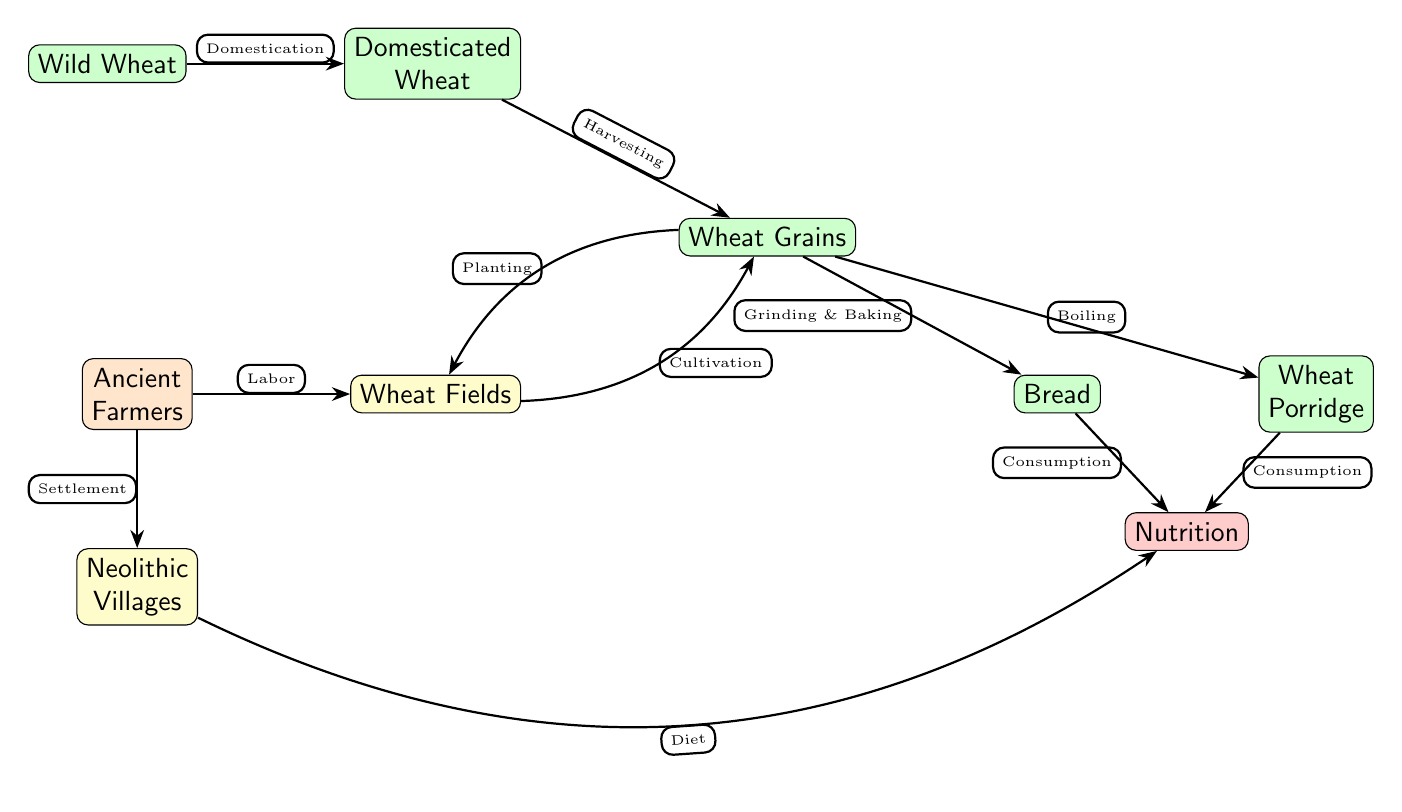What is the first node in the diagram? The first node in the diagram is "Wild Wheat," which serves as the starting point of the food chain, representing the natural, uncultivated form of wheat.
Answer: Wild Wheat What process occurs after domestication? After "Domestication," the next process in the diagram is "Harvesting," which occurs when the domesticated wheat is collected for further use.
Answer: Harvesting How many food nodes are present in the diagram? The diagram contains four food nodes: "Wild Wheat," "Domesticated Wheat," "Bread," and "Wheat Porridge," which are all related to the food derived from wheat cultivation.
Answer: 4 What is the relationship between "Wheat Grains" and "Bread"? The relationship between "Wheat Grains" and "Bread" is defined as "Grinding & Baking," indicating that wheat grains undergo processing to become bread.
Answer: Grinding & Baking What do "Villages" add to the food chain? "Villages" contribute to the food chain through "Diet," indicating the role of settlements in consuming the grain-based foods produced, tying together cultivation and consumption.
Answer: Diet How do "Ancient Farmers" relate to "Wheat Fields"? "Ancient Farmers" are involved in "Labor," relating to "Wheat Fields" as they work to cultivate and harvest the wheat necessary for their diet.
Answer: Labor What is the end product consumed from "Wheat Grains" other than "Bread"? The other end product consumed from "Wheat Grains" is "Wheat Porridge," which represents an additional way of utilizing the harvested grains in Neolithic diets.
Answer: Wheat Porridge How does "Nutrition" connect to both "Bread" and "Wheat Porridge"? "Nutrition" connects to both "Bread" and "Wheat Porridge" via "Consumption," indicating that both food items provide nutritional value to those who eat them.
Answer: Consumption What process is performed on "Wheat Grains" to provide wheat porridge? The process performed on "Wheat Grains" to produce "Wheat Porridge" is "Boiling," showing how the grains can be prepared in multiple ways for consumption.
Answer: Boiling 